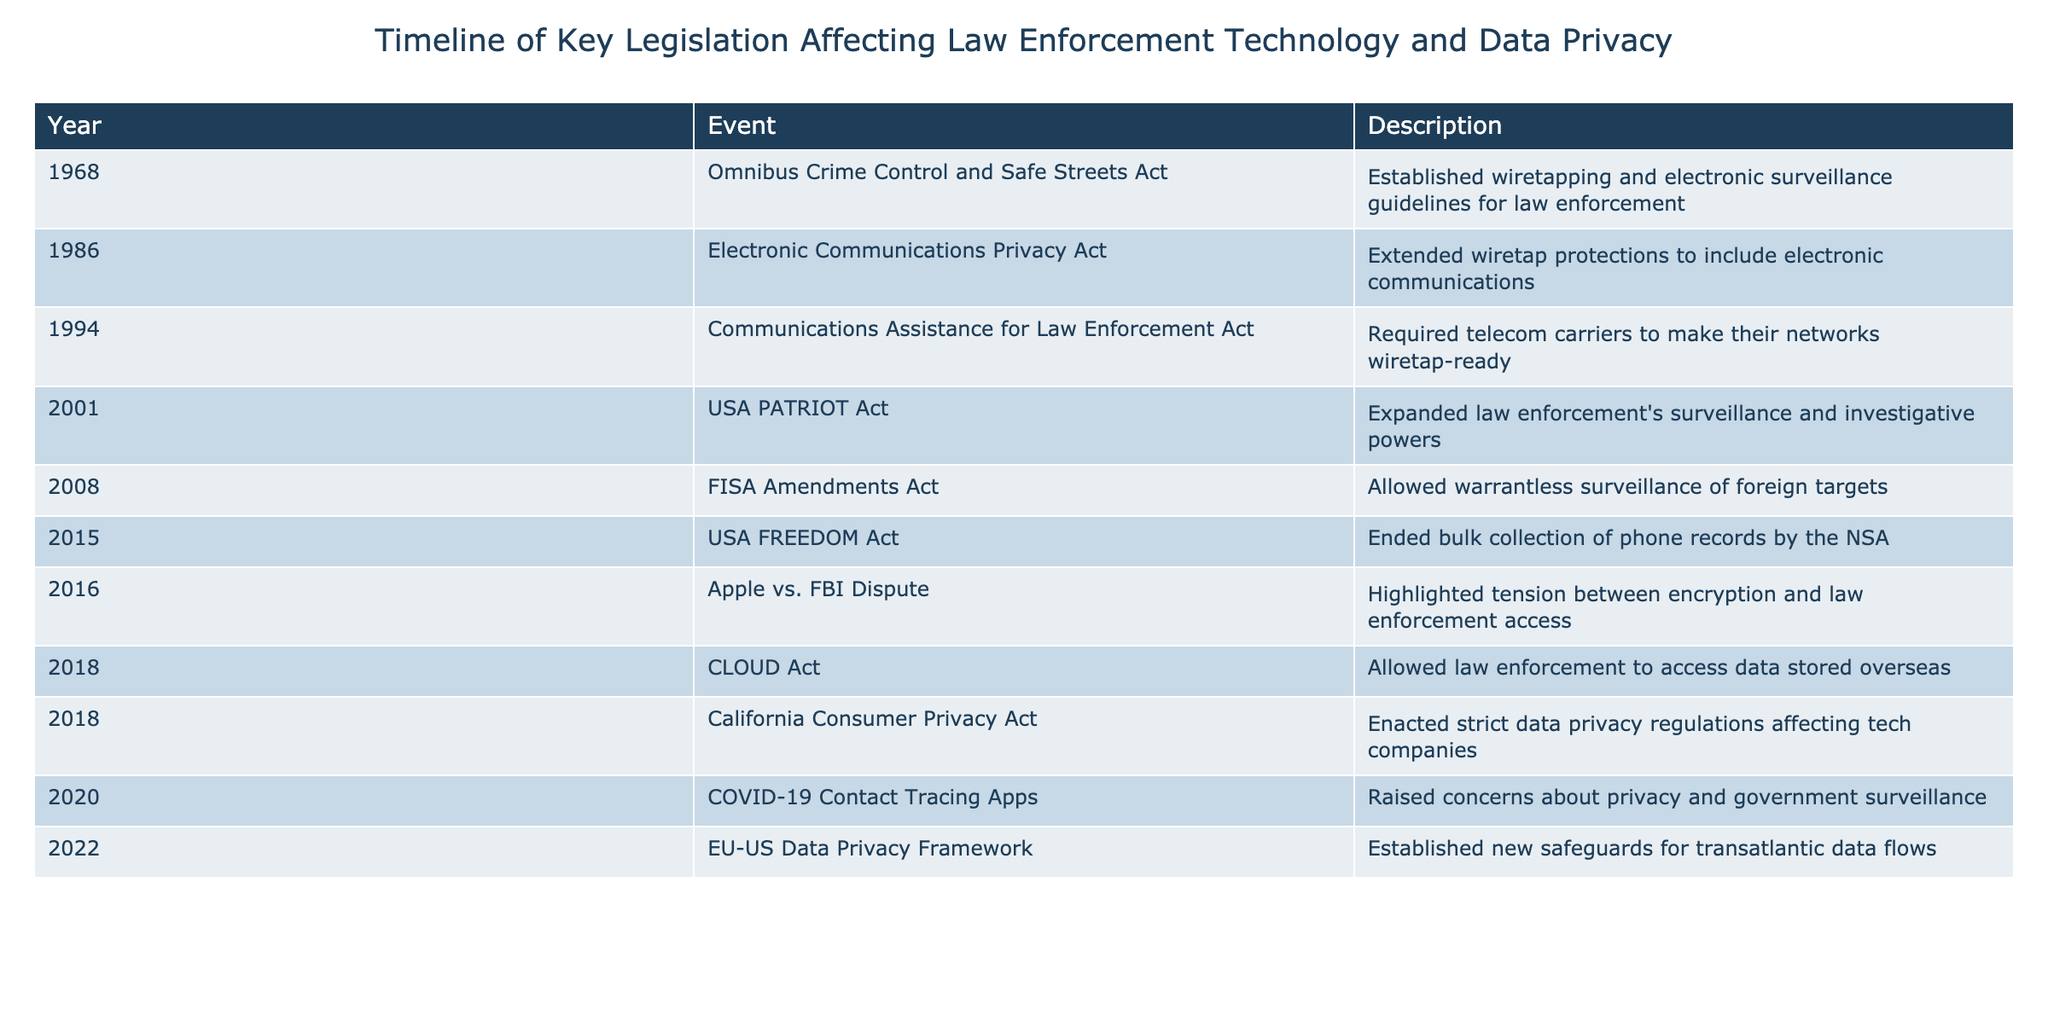What year was the Omnibus Crime Control and Safe Streets Act enacted? The table lists the Omnibus Crime Control and Safe Streets Act under the year 1968.
Answer: 1968 How many events were recorded in the timeline before the year 2000? The events before 2000, as seen in the table, are from 1968, 1986, 1994, and 2001, totaling 4 events.
Answer: 4 Did the USA FREEDOM Act occur before or after the USA PATRIOT Act? By examining the years in the table, the USA FREEDOM Act in 2015 follows the USA PATRIOT Act from 2001, so the answer is after.
Answer: After Which legislation allowed law enforcement to access data stored overseas? The table highlights the CLOUD Act in 2018 as the legislation that allowed access to data stored overseas.
Answer: CLOUD Act What is the total number of laws enacted in the timeline from 2018 onward? The events listed from 2018 onward include the CLOUD Act, California Consumer Privacy Act, COVID-19 Contact Tracing Apps, and EU-US Data Privacy Framework, for a total of 4 laws.
Answer: 4 Was wiretapping established as a guideline in 1968? The Omnibus Crime Control and Safe Streets Act from 1968 did in fact establish wiretapping and electronic surveillance guidelines.
Answer: Yes Which event in the table emphasized the conflict between encryption and law enforcement access? The Apple vs. FBI Dispute in 2016 is the event that highlighted the tension between encryption and law enforcement access.
Answer: Apple vs. FBI Dispute How many acts specifically addressed electronic communications and surveillance between 1986 and 2008? The acts in this range are the Electronic Communications Privacy Act (1986), Communications Assistance for Law Enforcement Act (1994), USA PATRIOT Act (2001), and FISA Amendments Act (2008), totaling 4 acts.
Answer: 4 What significant change did the USA FREEDOM Act bring to surveillance practices? The USA FREEDOM Act ended the bulk collection of phone records by the NSA, representing a significant reduction in surveillance.
Answer: Ended bulk collection of phone records What year did the California Consumer Privacy Act take effect? The table indicates that the California Consumer Privacy Act was enacted in the year 2018.
Answer: 2018 